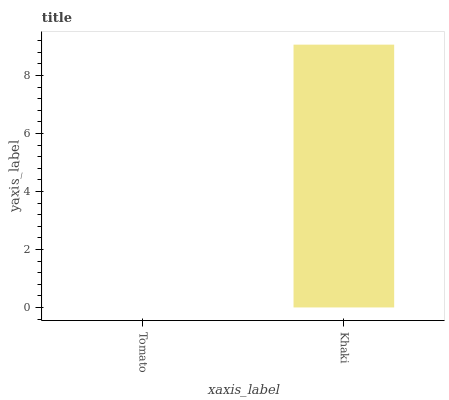Is Tomato the minimum?
Answer yes or no. Yes. Is Khaki the maximum?
Answer yes or no. Yes. Is Khaki the minimum?
Answer yes or no. No. Is Khaki greater than Tomato?
Answer yes or no. Yes. Is Tomato less than Khaki?
Answer yes or no. Yes. Is Tomato greater than Khaki?
Answer yes or no. No. Is Khaki less than Tomato?
Answer yes or no. No. Is Khaki the high median?
Answer yes or no. Yes. Is Tomato the low median?
Answer yes or no. Yes. Is Tomato the high median?
Answer yes or no. No. Is Khaki the low median?
Answer yes or no. No. 